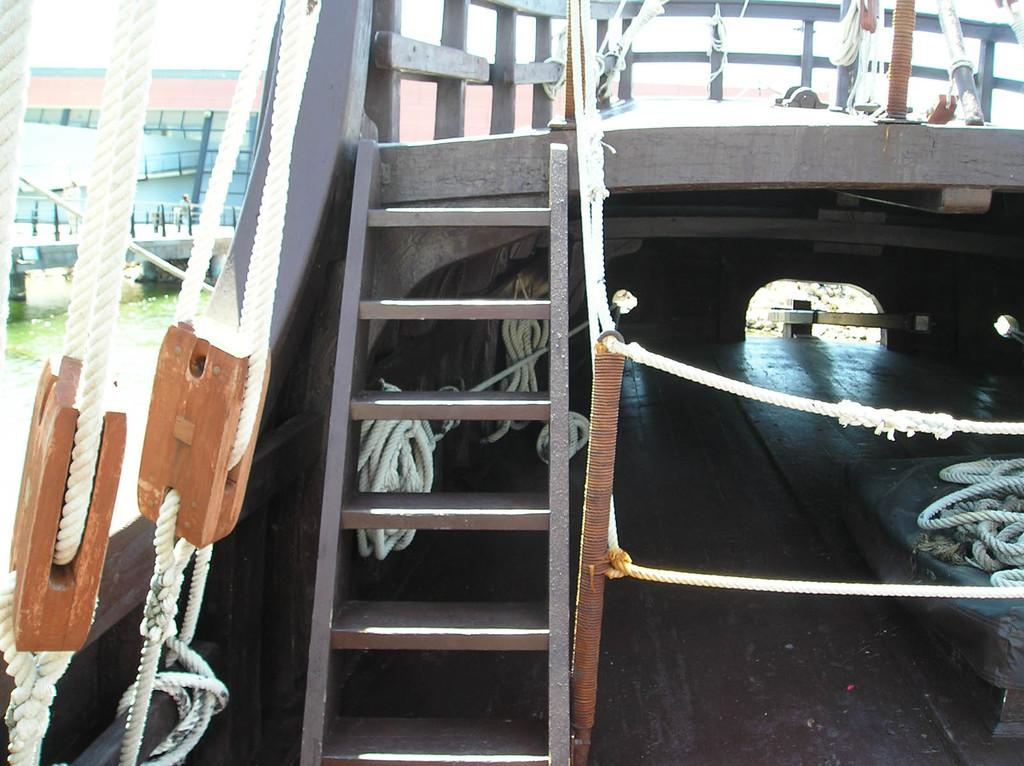What is the main subject of the image? There is a boat in the image. What are some objects associated with the boat? There are ropes and metal rods in the image. What can be seen in the background of the image? There is a bridge in the background of the image, and it is over water. Are there any vehicles visible in the image? Yes, there is a vehicle visible in the image. What type of drum can be heard playing in the image? There is no drum or sound present in the image; it is a still image of a boat, ropes, metal rods, a bridge, and a vehicle. Can you describe the alley where the boat is parked in the image? There is no alley mentioned or visible in the image; it features a boat, ropes, metal rods, a bridge, and a vehicle near water. 